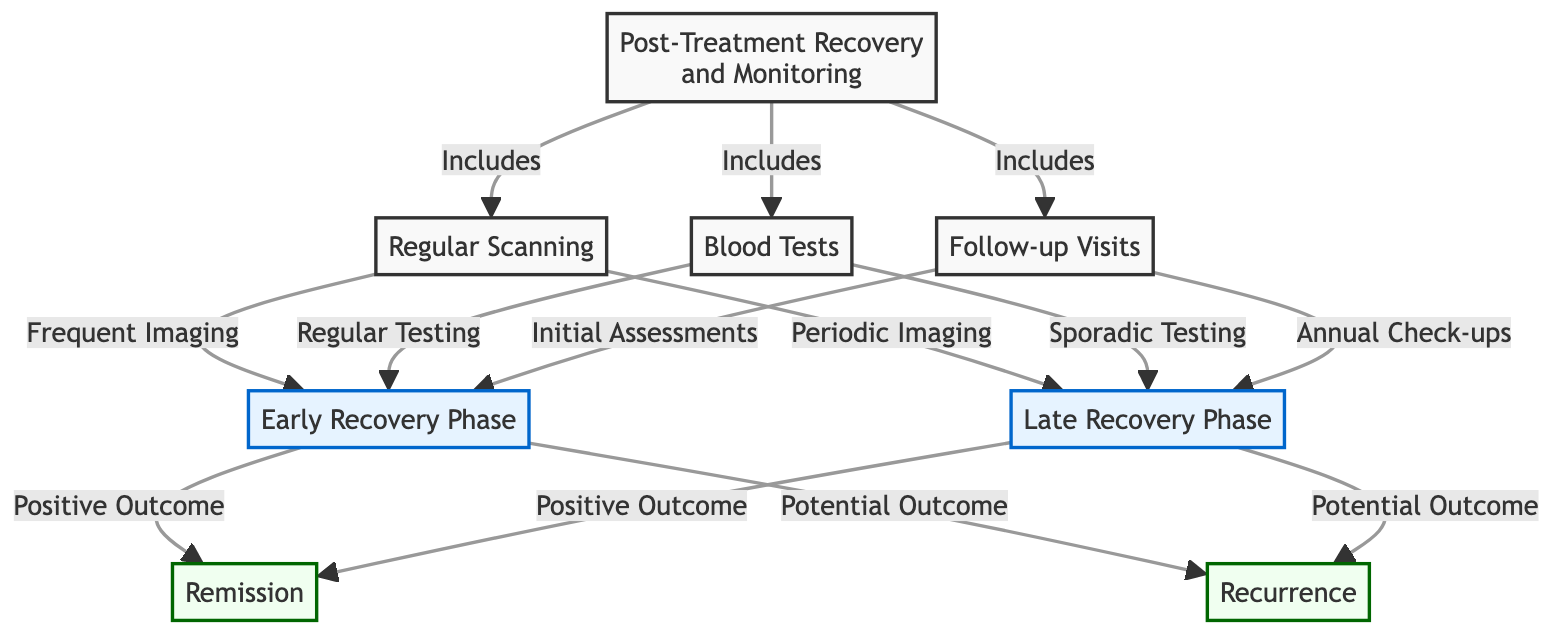What are the three main components of post-treatment recovery? The diagram shows that post-treatment recovery includes Regular Scanning, Blood Tests, and Follow-up Visits. These are all clearly listed as components under the main title "Post-Treatment Recovery and Monitoring."
Answer: Regular Scanning, Blood Tests, Follow-up Visits What follows the Early Recovery Phase in the diagram? Looking at the flow from the Early Recovery Phase, it connects to the Late Recovery Phase. Therefore, the immediate next phase after the Early Recovery Phase is the Late Recovery Phase.
Answer: Late Recovery Phase How many potential outcomes are listed in the diagram? The diagram outlines two potential outcomes: Remission and Recurrence. Counting these shows that there are a total of two potential outcomes depicted.
Answer: 2 What kind of imaging is associated with the Late Recovery Phase? The Late Recovery Phase is connected to "Periodic Imaging" through a directional arrow. This denotes that "Periodic Imaging" is performed during this phase.
Answer: Periodic Imaging What is the type of testing performed at the Early Recovery Phase? The flow from both Regular Testing and Initial Assessments leads to the Early Recovery Phase. This indicates that these testing types are specifically associated with this phase.
Answer: Regular Testing, Initial Assessments What happens in the Early Recovery Phase with a Positive Outcome? The Early Recovery Phase is linked to the Remission outcome with a line indicating a positive outcome. It suggests that if the Early Recovery Phase is positive, it leads to Remission.
Answer: Remission Which elements are involved in regular monitoring after treatment? The diagram shows interconnections from the main component labeled "Post-Treatment Recovery and Monitoring" to Regular Scanning, Blood Tests, and Follow-up Visits, indicating these are essential for regular monitoring.
Answer: Regular Scanning, Blood Tests, Follow-up Visits If the Early Recovery Phase has a Potential Outcome, where does it lead? The Early Recovery Phase points to both Remission and Recurrence. Therefore, a potential outcome in this phase could lead to either of these outcomes depending on the circumstances.
Answer: Remission, Recurrence 